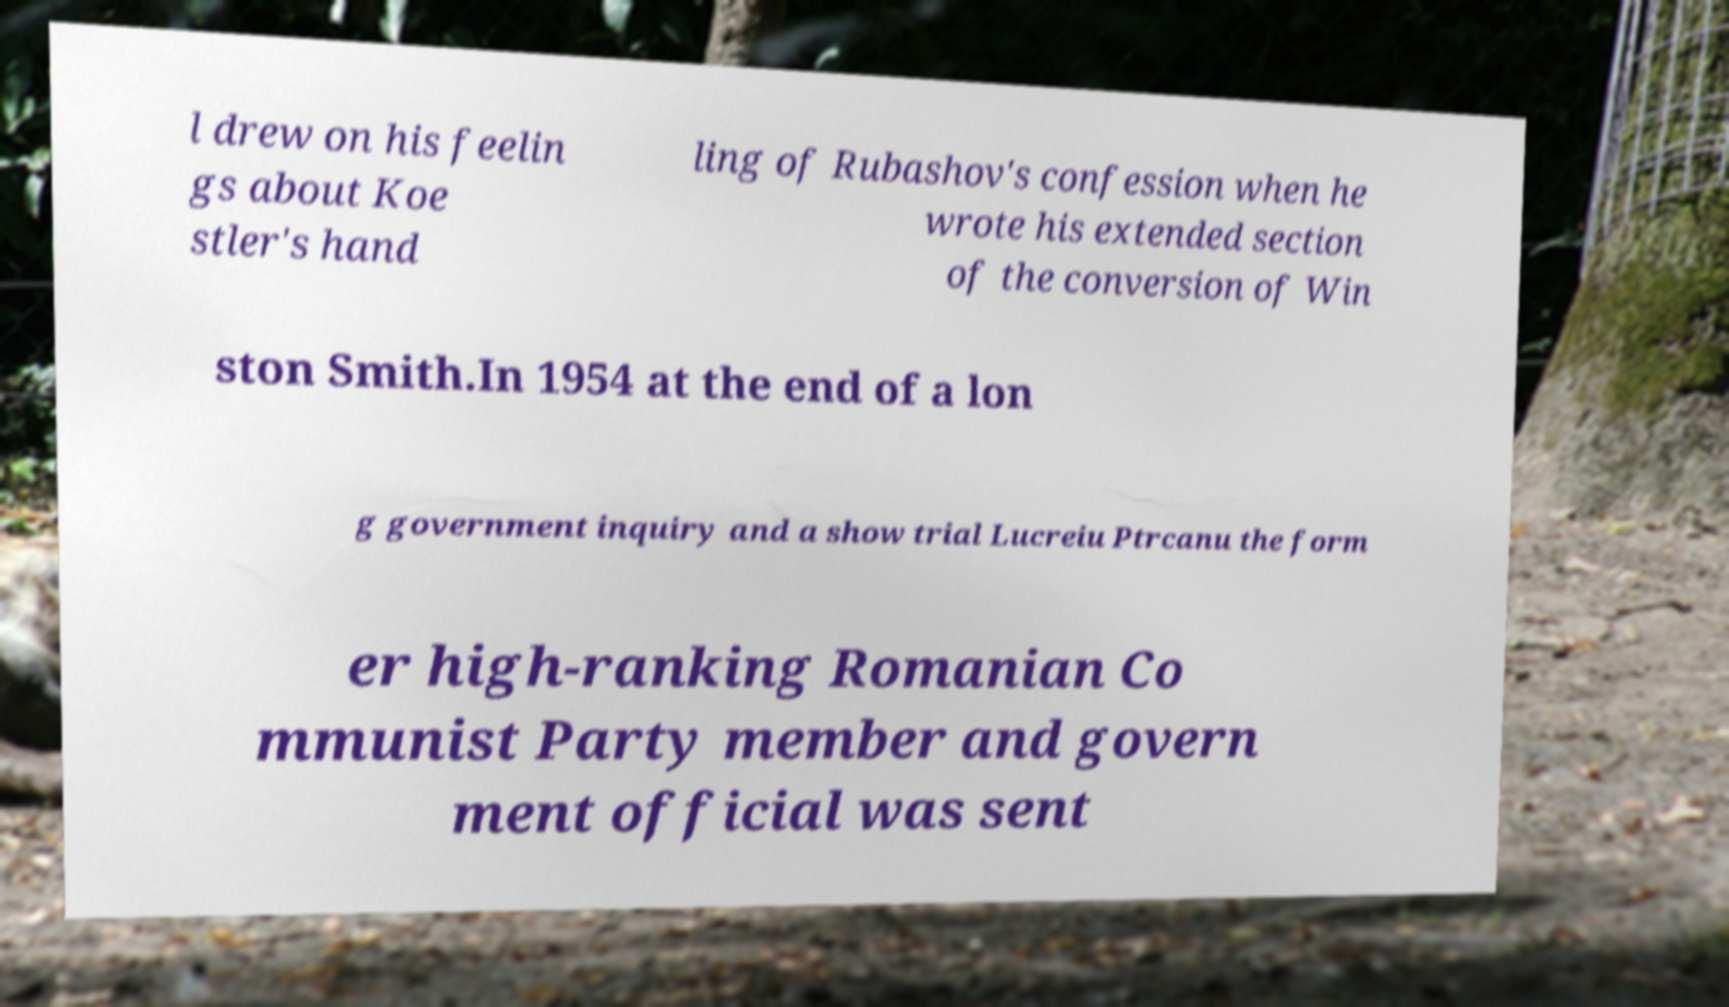Can you read and provide the text displayed in the image?This photo seems to have some interesting text. Can you extract and type it out for me? l drew on his feelin gs about Koe stler's hand ling of Rubashov's confession when he wrote his extended section of the conversion of Win ston Smith.In 1954 at the end of a lon g government inquiry and a show trial Lucreiu Ptrcanu the form er high-ranking Romanian Co mmunist Party member and govern ment official was sent 